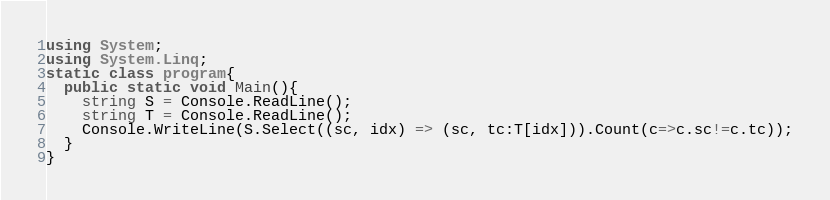<code> <loc_0><loc_0><loc_500><loc_500><_C#_>using System;
using System.Linq;
static class program{
  public static void Main(){
    string S = Console.ReadLine();
    string T = Console.ReadLine();
    Console.WriteLine(S.Select((sc, idx) => (sc, tc:T[idx])).Count(c=>c.sc!=c.tc));
  }
}
</code> 